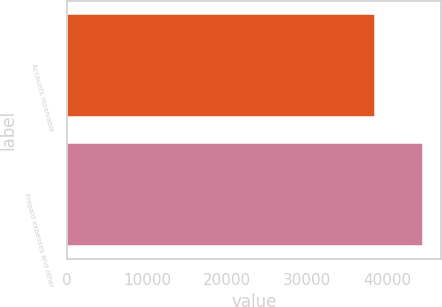Convert chart. <chart><loc_0><loc_0><loc_500><loc_500><bar_chart><fcel>Accounts receivable<fcel>Prepaid expenses and other<nl><fcel>38511<fcel>44508<nl></chart> 